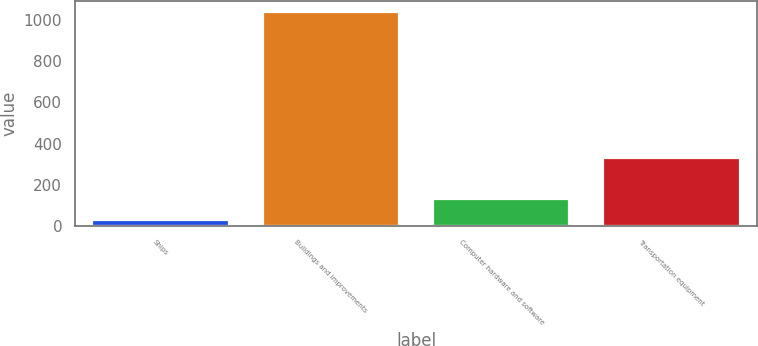<chart> <loc_0><loc_0><loc_500><loc_500><bar_chart><fcel>Ships<fcel>Buildings and improvements<fcel>Computer hardware and software<fcel>Transportation equipment<nl><fcel>30<fcel>1040<fcel>131<fcel>330<nl></chart> 